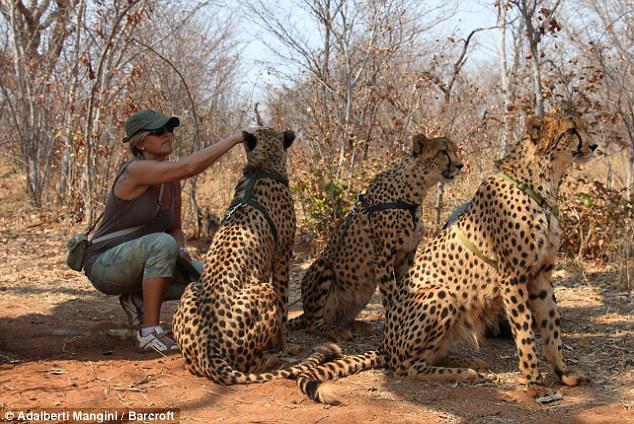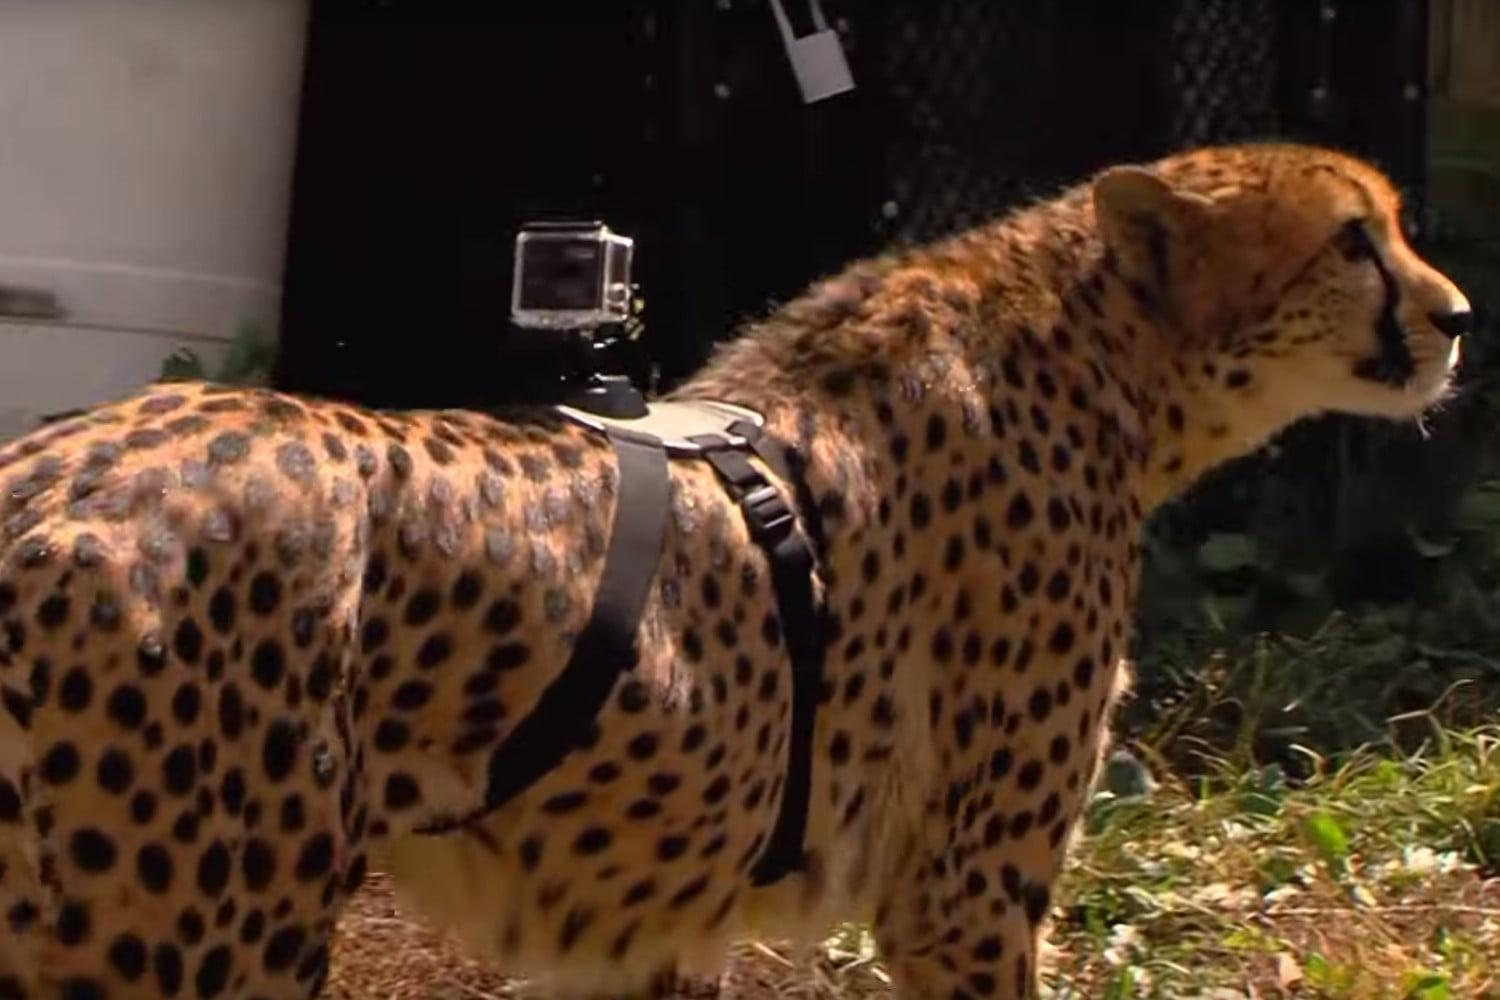The first image is the image on the left, the second image is the image on the right. For the images displayed, is the sentence "There are exactly three cheetahs in the left image." factually correct? Answer yes or no. Yes. The first image is the image on the left, the second image is the image on the right. Considering the images on both sides, is "The left image shows at least one cheetah standing in front of mounded dirt, and the right image contains just one cheetah." valid? Answer yes or no. No. 